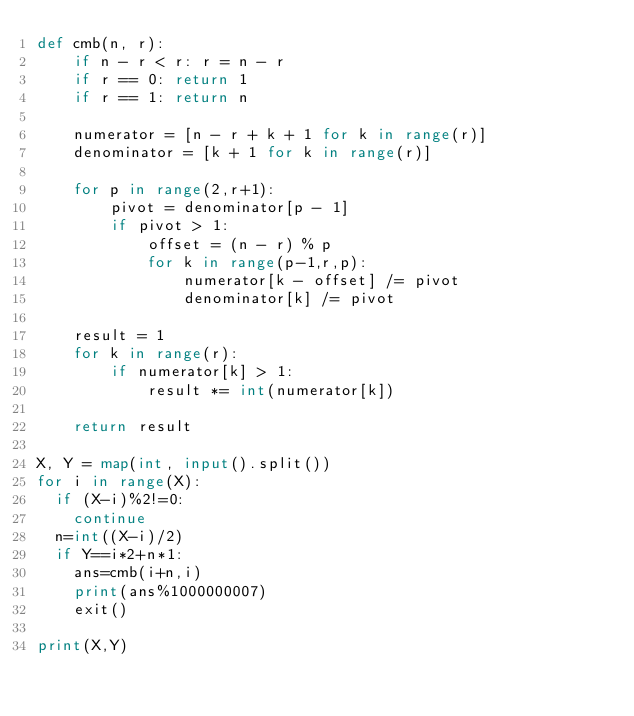<code> <loc_0><loc_0><loc_500><loc_500><_Python_>def cmb(n, r):
    if n - r < r: r = n - r
    if r == 0: return 1
    if r == 1: return n

    numerator = [n - r + k + 1 for k in range(r)]
    denominator = [k + 1 for k in range(r)]

    for p in range(2,r+1):
        pivot = denominator[p - 1]
        if pivot > 1:
            offset = (n - r) % p
            for k in range(p-1,r,p):
                numerator[k - offset] /= pivot
                denominator[k] /= pivot

    result = 1
    for k in range(r):
        if numerator[k] > 1:
            result *= int(numerator[k])

    return result

X, Y = map(int, input().split())
for i in range(X):
  if (X-i)%2!=0:
    continue
  n=int((X-i)/2)
  if Y==i*2+n*1:
    ans=cmb(i+n,i)
    print(ans%1000000007)
    exit()
    
print(X,Y)</code> 